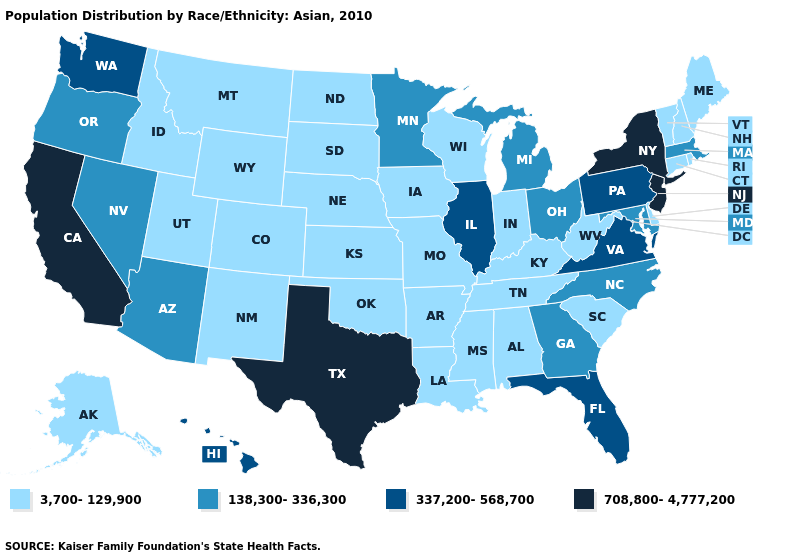Does the first symbol in the legend represent the smallest category?
Concise answer only. Yes. Name the states that have a value in the range 3,700-129,900?
Answer briefly. Alabama, Alaska, Arkansas, Colorado, Connecticut, Delaware, Idaho, Indiana, Iowa, Kansas, Kentucky, Louisiana, Maine, Mississippi, Missouri, Montana, Nebraska, New Hampshire, New Mexico, North Dakota, Oklahoma, Rhode Island, South Carolina, South Dakota, Tennessee, Utah, Vermont, West Virginia, Wisconsin, Wyoming. Which states hav the highest value in the West?
Be succinct. California. Does Missouri have a lower value than Alaska?
Give a very brief answer. No. What is the value of Tennessee?
Quick response, please. 3,700-129,900. Name the states that have a value in the range 3,700-129,900?
Quick response, please. Alabama, Alaska, Arkansas, Colorado, Connecticut, Delaware, Idaho, Indiana, Iowa, Kansas, Kentucky, Louisiana, Maine, Mississippi, Missouri, Montana, Nebraska, New Hampshire, New Mexico, North Dakota, Oklahoma, Rhode Island, South Carolina, South Dakota, Tennessee, Utah, Vermont, West Virginia, Wisconsin, Wyoming. How many symbols are there in the legend?
Write a very short answer. 4. Does Washington have the highest value in the USA?
Write a very short answer. No. What is the value of Connecticut?
Give a very brief answer. 3,700-129,900. How many symbols are there in the legend?
Keep it brief. 4. What is the value of Utah?
Give a very brief answer. 3,700-129,900. Name the states that have a value in the range 708,800-4,777,200?
Be succinct. California, New Jersey, New York, Texas. What is the value of Kansas?
Short answer required. 3,700-129,900. Name the states that have a value in the range 337,200-568,700?
Give a very brief answer. Florida, Hawaii, Illinois, Pennsylvania, Virginia, Washington. What is the highest value in the USA?
Give a very brief answer. 708,800-4,777,200. 